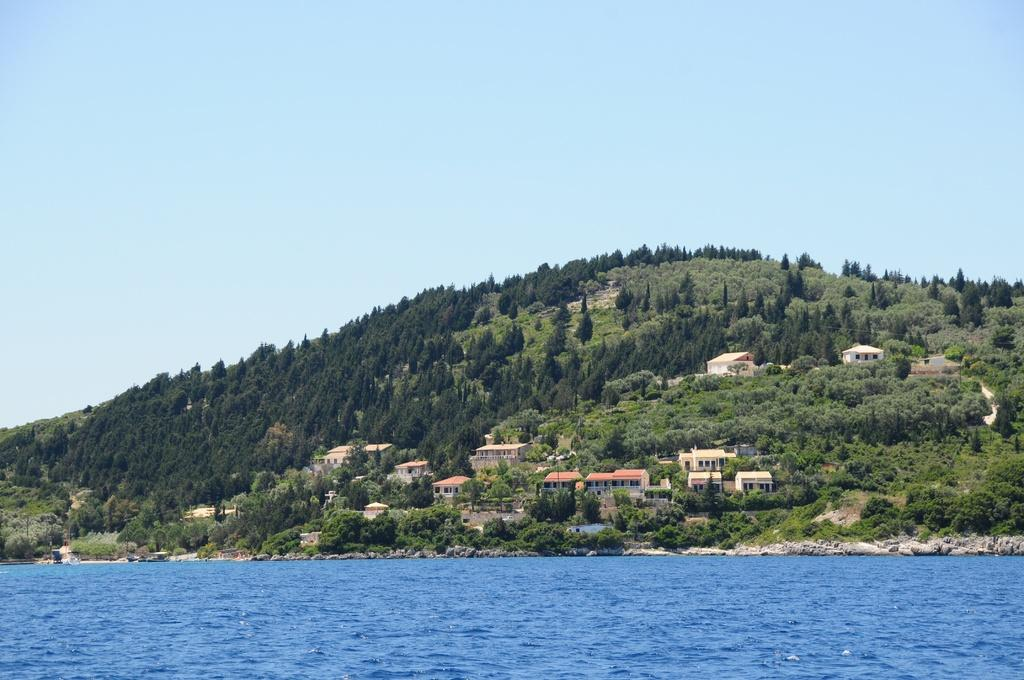What type of natural elements can be seen in the image? There are many trees in the image. What man-made structures are present in the image? There are buildings in the image. What body of water is visible in the image? There is water visible in the image. What type of ground surface is present in the image? There are stones in the image. What is the color of the sky in the image? The sky is pale blue in the image. What type of frame is used to catch fish in the image? There is no frame or fishing activity present in the image. What time of day is it in the image? The provided facts do not specify the time of day, so it cannot be determined from the image. 